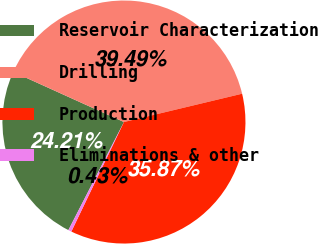Convert chart to OTSL. <chart><loc_0><loc_0><loc_500><loc_500><pie_chart><fcel>Reservoir Characterization<fcel>Drilling<fcel>Production<fcel>Eliminations & other<nl><fcel>24.21%<fcel>39.49%<fcel>35.87%<fcel>0.43%<nl></chart> 